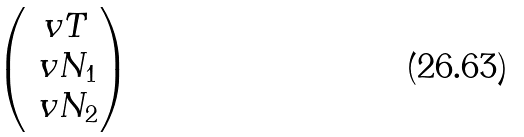Convert formula to latex. <formula><loc_0><loc_0><loc_500><loc_500>\begin{pmatrix} \ v { T } \, \\ \ v { N _ { 1 } } \\ \ v { N _ { 2 } } \end{pmatrix}</formula> 